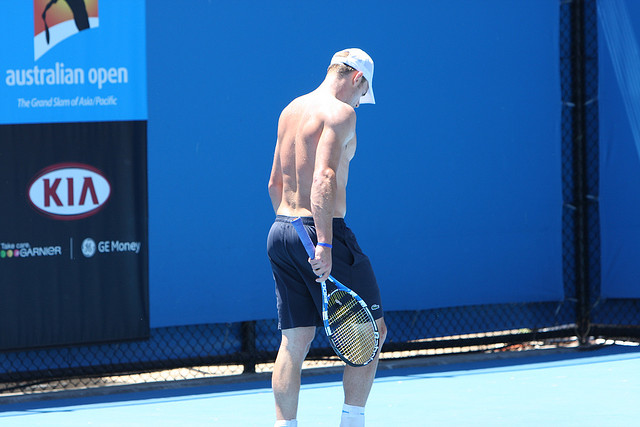Imagine a story where this tennis player is secretly a superhero. Where does he hide his gear? In a thrilling twist, the tennis player is not just a world-class athlete but also a superhero. After every match or training session, he subtly retreats to a hidden compartment under the tennis court. This high-tech hideaway is ingeniously concealed beneath a removable panel on the court’s surface, typically under the guise of maintenance access. Inside, it’s equipped with an array of superhero gear, from his high-performance suit to advanced gadgets. The facility is managed by his trusted friend and tech-genius teammate, who ensures that everything is in place for the superhero's next mission. The duality of his life is a well-guarded secret, only known to a few close allies who help cover for him during critical moments when the world needs saving. 